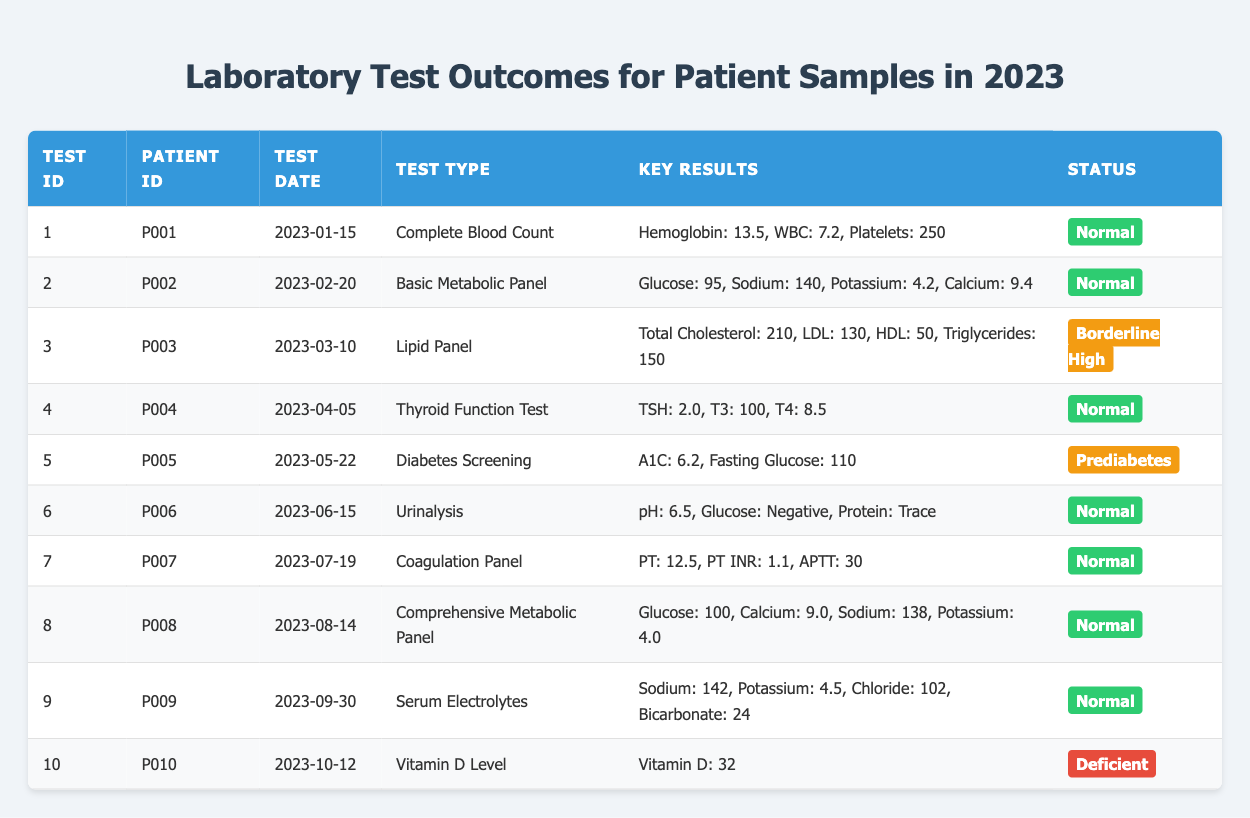What is the test type for patient P005? By locating the row corresponding to patient P005, we can see that under the "Test Type" column, it is listed as "Diabetes Screening."
Answer: Diabetes Screening How many tests have a result status of "Normal"? Counting the rows with "Normal" in the "Status" column gives seven occurrences for tests 1, 2, 4, 6, 7, 8, and 9.
Answer: 7 What was the fasting glucose level for patient P005? If we find the row for patient P005, the fasting glucose level is stated in the "Key Results" column as "Fasting Glucose: 110."
Answer: 110 Is the potassium level for the Comprehensive Metabolic Panel test within the normal range (considered typically to be around 3.5 - 5.0)? Looking at the potassium value in the Comprehensive Metabolic Panel row (test ID 8), which is 4.0, we find that this value falls within the normal range.
Answer: Yes What is the average hemoglobin level for the tests with a "Normal" status? The hemoglobin values for the Normal status tests are 13.5 (test ID 1) and no other hemoglobin value is reported for the other tests categorized as normal. To find the average, we just use this single hemoglobin level: average = 13.5/1 = 13.5.
Answer: 13.5 Which patient has the highest total cholesterol, and what was the value? By checking the Lipid Panel results corresponding to patient P003, we find the total cholesterol is 210. Since this is the only cholesterol value in the data, it is the highest.
Answer: P003, 210 Was there any test performed that indicated a deficiency in vitamin D? In the "Vitamin D Level" test for patient P010, it clearly states the status is "Deficient." Therefore, the answer to this query is affirmative.
Answer: Yes How many patients received borderline results in their tests? In the table, the rows for tests with borderline results include test ID 3 and test ID 5. Therefore, there are two patients who received borderline results.
Answer: 2 What is the difference in the number of tests categorized as "Normal" versus "Abnormal"? "Normal" tests count to 7, and for "Abnormal" tests there is only 1 (Vitamin D), so the difference would be 7 - 1 = 6.
Answer: 6 What is the average A1C level reported for the tests, and what does it suggest about patient P005's results? In the dataset, only patient P005 has an A1C level reported at 6.2 and is categorized as "Prediabetes." Therefore, the average A1C is just 6.2 which indicates a risk level for diabetes impact.
Answer: 6.2 